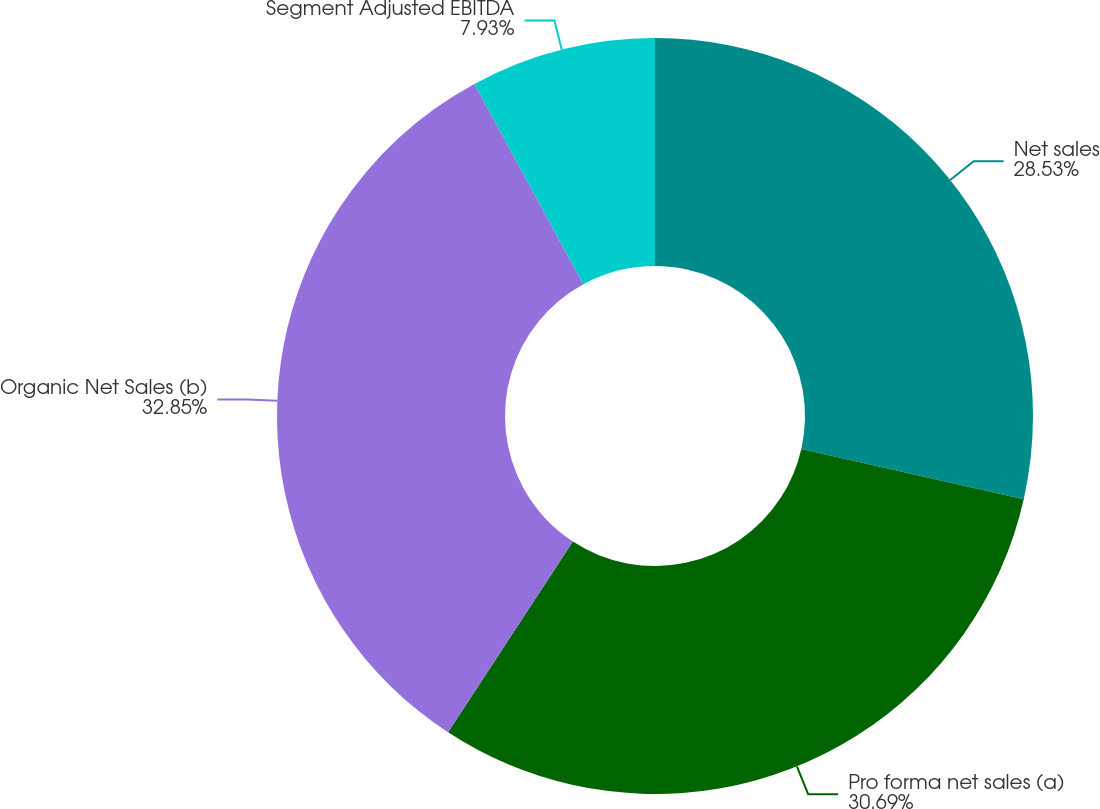<chart> <loc_0><loc_0><loc_500><loc_500><pie_chart><fcel>Net sales<fcel>Pro forma net sales (a)<fcel>Organic Net Sales (b)<fcel>Segment Adjusted EBITDA<nl><fcel>28.53%<fcel>30.69%<fcel>32.85%<fcel>7.93%<nl></chart> 